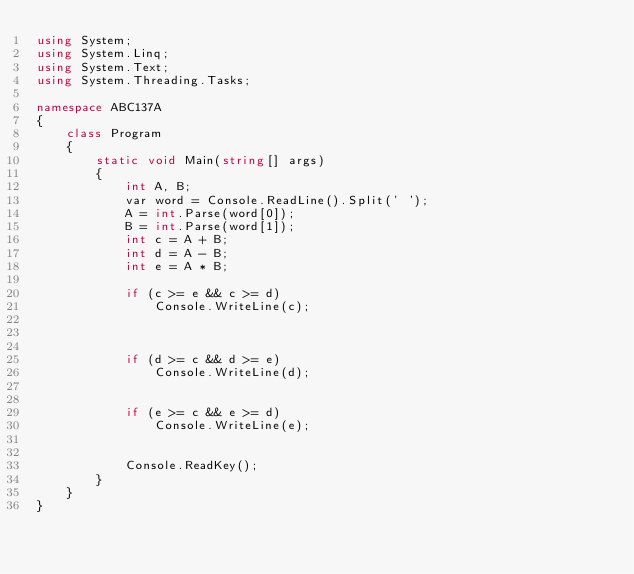Convert code to text. <code><loc_0><loc_0><loc_500><loc_500><_C#_>using System;
using System.Linq;
using System.Text;
using System.Threading.Tasks;

namespace ABC137A
{
    class Program
    {
        static void Main(string[] args)
        {
            int A, B;
            var word = Console.ReadLine().Split(' ');
            A = int.Parse(word[0]);
            B = int.Parse(word[1]);
            int c = A + B;
            int d = A - B;
            int e = A * B;

            if (c >= e && c >= d)
                Console.WriteLine(c);
           
                

            if (d >= c && d >= e)
                Console.WriteLine(d);
           

            if (e >= c && e >= d)
                Console.WriteLine(e);
          

            Console.ReadKey();
        }
    }
}
</code> 